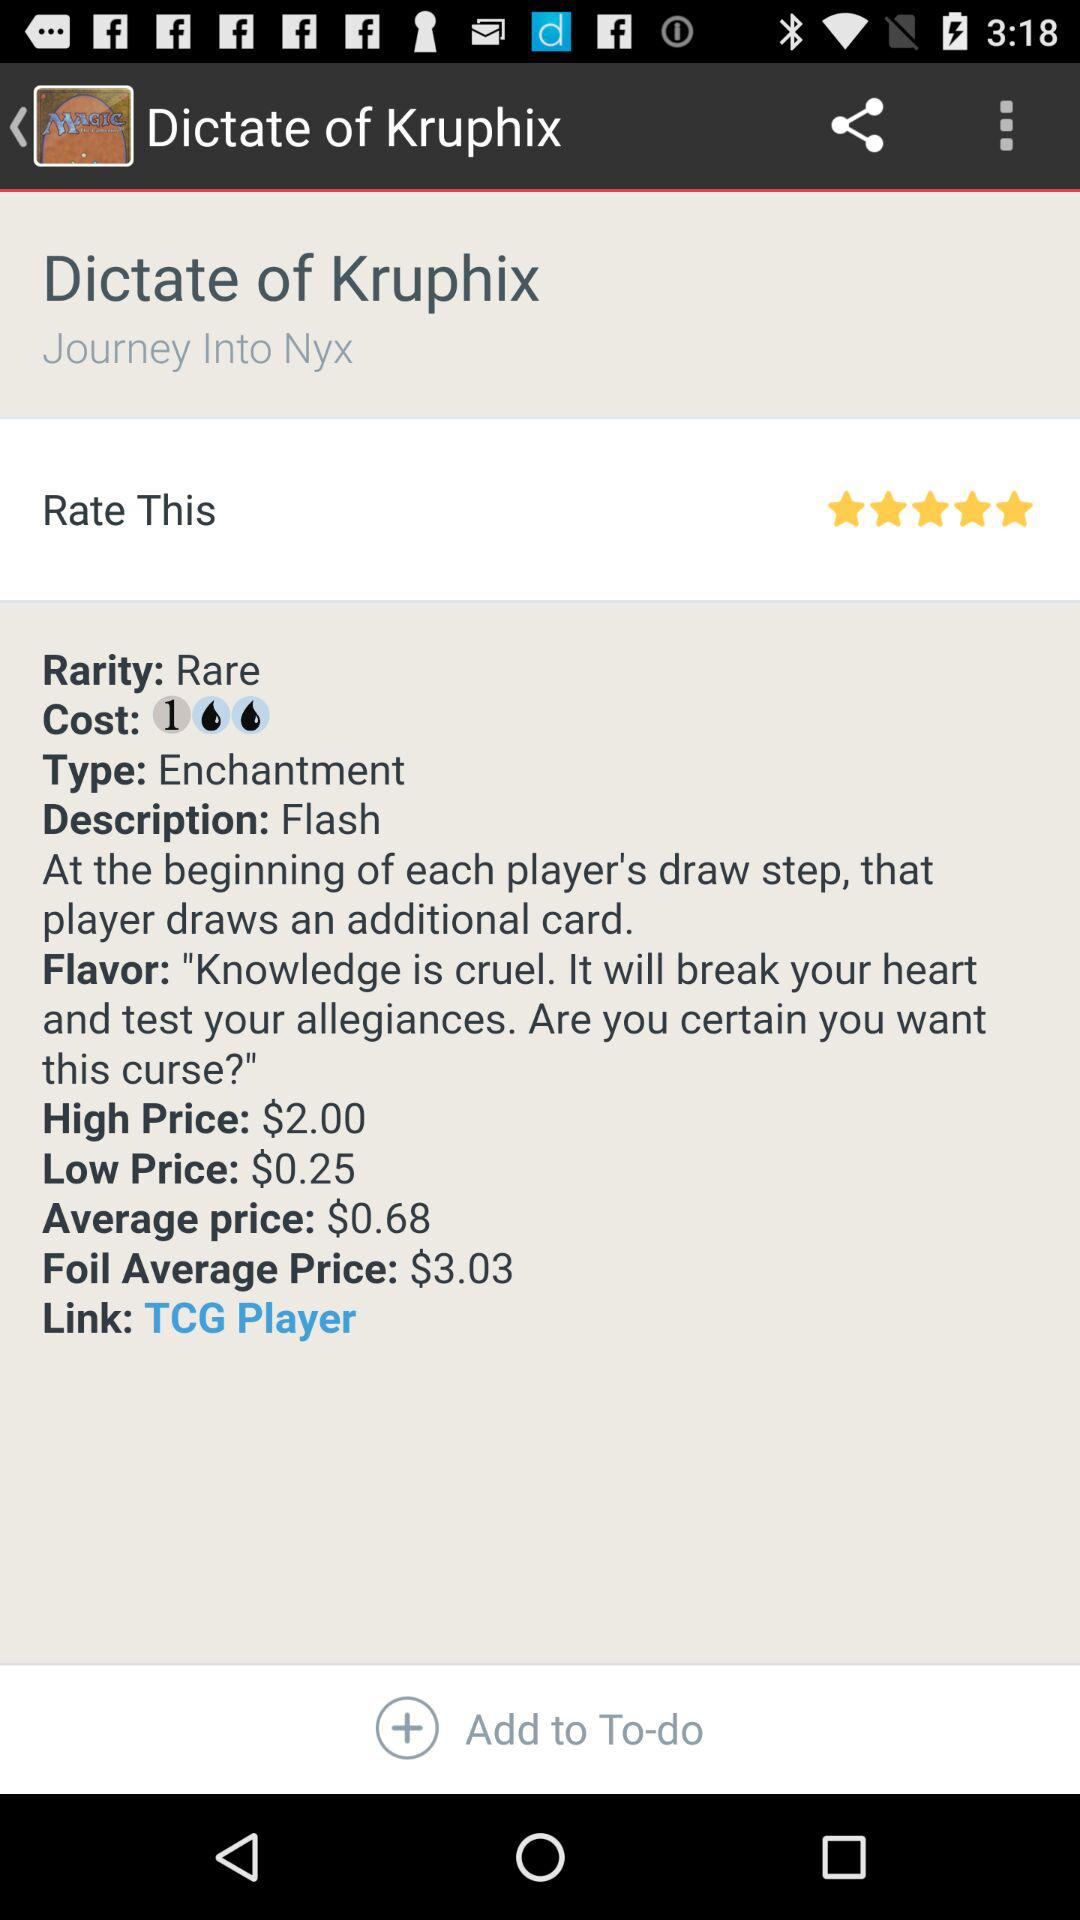What is the rating of "Dictate of Kruphix"? The rating is 5 stars. 